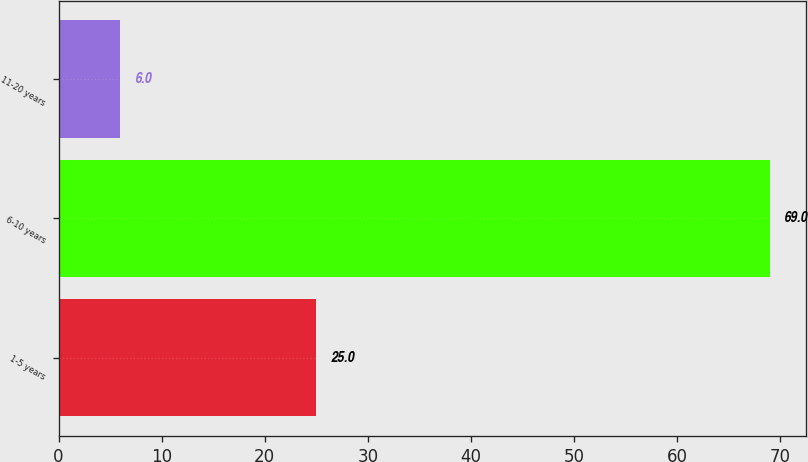<chart> <loc_0><loc_0><loc_500><loc_500><bar_chart><fcel>1-5 years<fcel>6-10 years<fcel>11-20 years<nl><fcel>25<fcel>69<fcel>6<nl></chart> 